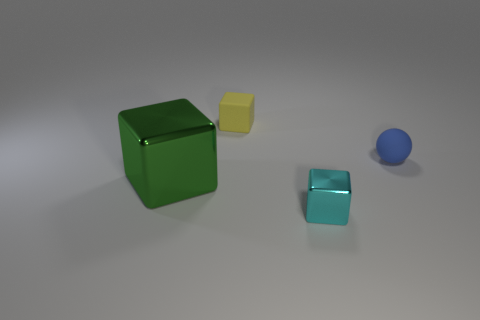There is a block behind the sphere; is its size the same as the tiny blue rubber object?
Your answer should be compact. Yes. Does the tiny matte sphere have the same color as the rubber cube?
Your answer should be very brief. No. How many small things are there?
Provide a short and direct response. 3. How many spheres are either large objects or metallic objects?
Your answer should be very brief. 0. What number of spheres are in front of the shiny thing that is to the left of the cyan metal object?
Provide a short and direct response. 0. Are the cyan thing and the blue thing made of the same material?
Your answer should be very brief. No. Is there a tiny blue thing made of the same material as the sphere?
Give a very brief answer. No. There is a metal thing left of the tiny cube that is behind the big green shiny object left of the tiny metallic thing; what color is it?
Provide a succinct answer. Green. How many green objects are either small balls or big shiny cubes?
Make the answer very short. 1. What number of other tiny blue rubber things have the same shape as the tiny blue object?
Your response must be concise. 0. 